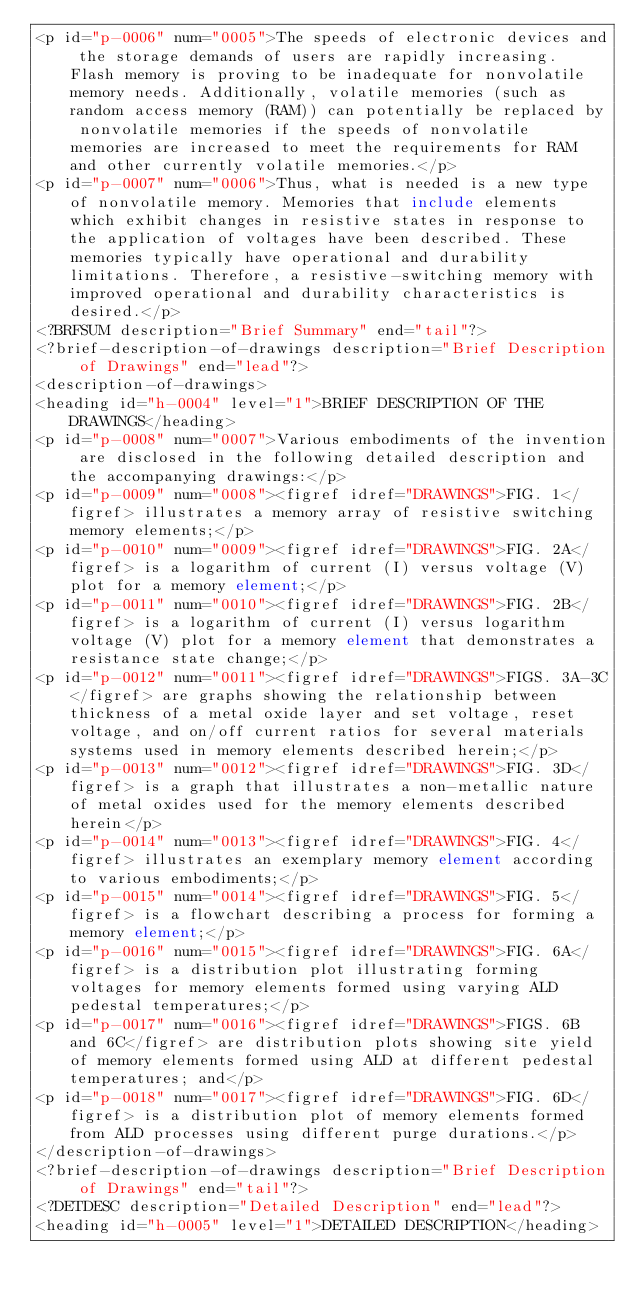Convert code to text. <code><loc_0><loc_0><loc_500><loc_500><_XML_><p id="p-0006" num="0005">The speeds of electronic devices and the storage demands of users are rapidly increasing. Flash memory is proving to be inadequate for nonvolatile memory needs. Additionally, volatile memories (such as random access memory (RAM)) can potentially be replaced by nonvolatile memories if the speeds of nonvolatile memories are increased to meet the requirements for RAM and other currently volatile memories.</p>
<p id="p-0007" num="0006">Thus, what is needed is a new type of nonvolatile memory. Memories that include elements which exhibit changes in resistive states in response to the application of voltages have been described. These memories typically have operational and durability limitations. Therefore, a resistive-switching memory with improved operational and durability characteristics is desired.</p>
<?BRFSUM description="Brief Summary" end="tail"?>
<?brief-description-of-drawings description="Brief Description of Drawings" end="lead"?>
<description-of-drawings>
<heading id="h-0004" level="1">BRIEF DESCRIPTION OF THE DRAWINGS</heading>
<p id="p-0008" num="0007">Various embodiments of the invention are disclosed in the following detailed description and the accompanying drawings:</p>
<p id="p-0009" num="0008"><figref idref="DRAWINGS">FIG. 1</figref> illustrates a memory array of resistive switching memory elements;</p>
<p id="p-0010" num="0009"><figref idref="DRAWINGS">FIG. 2A</figref> is a logarithm of current (I) versus voltage (V) plot for a memory element;</p>
<p id="p-0011" num="0010"><figref idref="DRAWINGS">FIG. 2B</figref> is a logarithm of current (I) versus logarithm voltage (V) plot for a memory element that demonstrates a resistance state change;</p>
<p id="p-0012" num="0011"><figref idref="DRAWINGS">FIGS. 3A-3C</figref> are graphs showing the relationship between thickness of a metal oxide layer and set voltage, reset voltage, and on/off current ratios for several materials systems used in memory elements described herein;</p>
<p id="p-0013" num="0012"><figref idref="DRAWINGS">FIG. 3D</figref> is a graph that illustrates a non-metallic nature of metal oxides used for the memory elements described herein</p>
<p id="p-0014" num="0013"><figref idref="DRAWINGS">FIG. 4</figref> illustrates an exemplary memory element according to various embodiments;</p>
<p id="p-0015" num="0014"><figref idref="DRAWINGS">FIG. 5</figref> is a flowchart describing a process for forming a memory element;</p>
<p id="p-0016" num="0015"><figref idref="DRAWINGS">FIG. 6A</figref> is a distribution plot illustrating forming voltages for memory elements formed using varying ALD pedestal temperatures;</p>
<p id="p-0017" num="0016"><figref idref="DRAWINGS">FIGS. 6B and 6C</figref> are distribution plots showing site yield of memory elements formed using ALD at different pedestal temperatures; and</p>
<p id="p-0018" num="0017"><figref idref="DRAWINGS">FIG. 6D</figref> is a distribution plot of memory elements formed from ALD processes using different purge durations.</p>
</description-of-drawings>
<?brief-description-of-drawings description="Brief Description of Drawings" end="tail"?>
<?DETDESC description="Detailed Description" end="lead"?>
<heading id="h-0005" level="1">DETAILED DESCRIPTION</heading></code> 